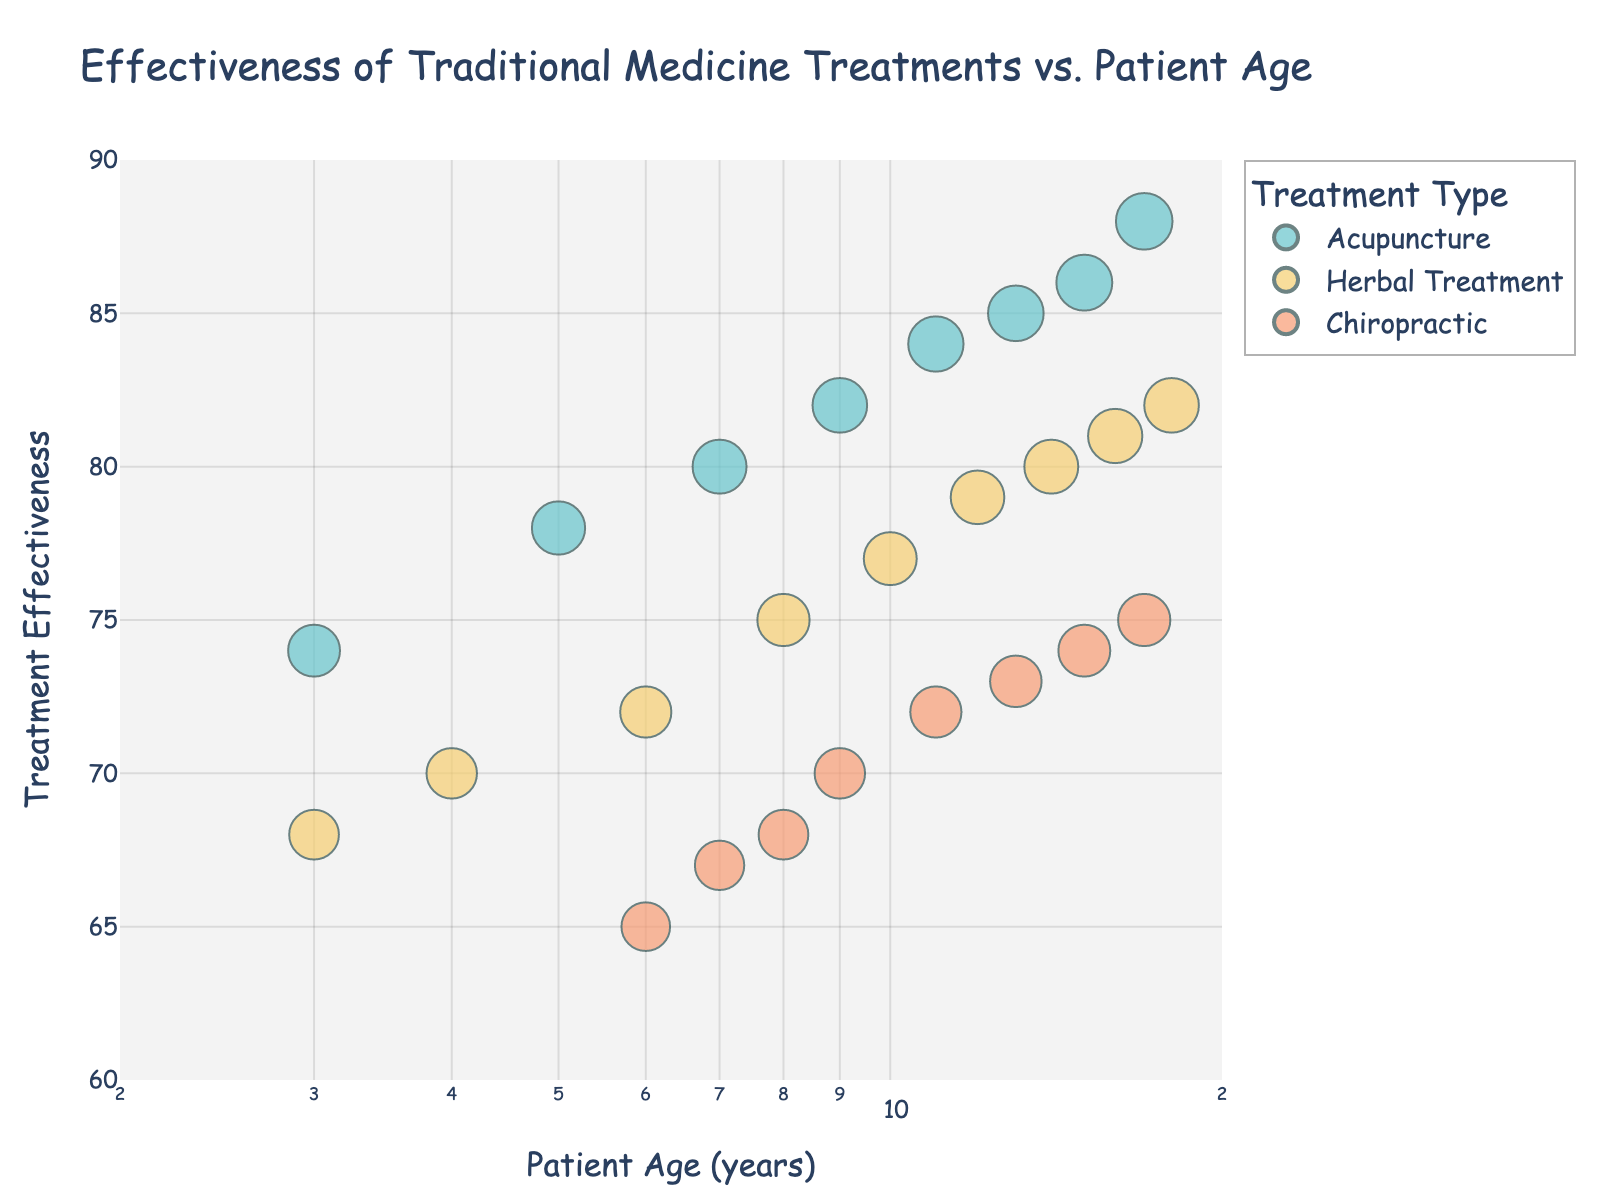What's the title of the figure? The title of a figure is typically located at the top and gives a summary of what the figure is about. In this case, the title is "Effectiveness of Traditional Medicine Treatments vs. Patient Age," which indicates the plot explores the relationship between traditional medicine effectiveness and the patients’ ages.
Answer: Effectiveness of Traditional Medicine Treatments vs. Patient Age How many types of traditional medicine treatments are shown in the plot? The plot uses different colors to represent different types of traditional medicine treatments. By looking at the legend, we can determine the number of distinct treatment types.
Answer: Three Which traditional medicine treatment has the highest effectiveness for the oldest patient? To answer this, find the data point representing the oldest patient (age 18), then check the effectiveness score and corresponding treatment type. The data shows the highest effectiveness for the patient aged 18 is from Herbal Treatment with an effectiveness of 82.
Answer: Herbal Treatment At what age does Acupuncture first reach an effectiveness of 80 or higher? Locate the points in the plot colored for Acupuncture and check the effectiveness values, noting the corresponding ages. The minimum age for Acupuncture effectiveness reaching 80 or higher is 7.
Answer: 7 What is the overall trend of effectiveness for Chiropractic treatment as patient age increases from 6 to 17? Track the data points representing Chiropractic treatment between ages 6 and 17, and note the effectiveness values. The overall trend can be evaluated by observing whether the values generally increase, decrease, or remain constant. Here, the effectiveness values show a slight, steady increase.
Answer: Slight, steady increase Which age has the most data points, and how many data points are there? Identify the age(s) with the highest frequency of data points by counting the points vertically aligned at each age along the x-axis. Age 6 and Age 7 each have three data points.
Answer: Age 6 and Age 7, three points each What is the average effectiveness of Acupuncture across all age groups? Sum the effectiveness values for Acupuncture and then divide by the total number of Acupuncture data points (7 total, values are 74, 78, 80, 82, 84, 85, 86). Calculation: (74 + 78 + 80 + 82 + 84 + 85 + 86) / 7 = 81.3
Answer: 81.3 How does the effectiveness of Herbal Treatment change from ages 4 to 18? Compare the values of Herbal Treatment effectiveness at ages 4, 6, 8, 10, 12, 14, 16, and 18. The values are 70, 72, 75, 77, 79, 80, 81, 82, showing a generally increasing trend over time.
Answer: Generally increasing Which traditional medicine treatment shows the most stability in effectiveness across different ages? Stability can be seen by examining the spread and range of the effectiveness values for each treatment type across the ages. Chiropractic, spreading narrowly between 65 and 75, shows the least variation, indicating the most stability.
Answer: Chiropractic What's the difference in effectiveness between Acupuncture and Chiropractic treatments at age 11? Identify the effectiveness values for Acupuncture (84) and Chiropractic (72) at age 11, then subtract the latter from the former to find the difference: 84 - 72 = 12.
Answer: 12 